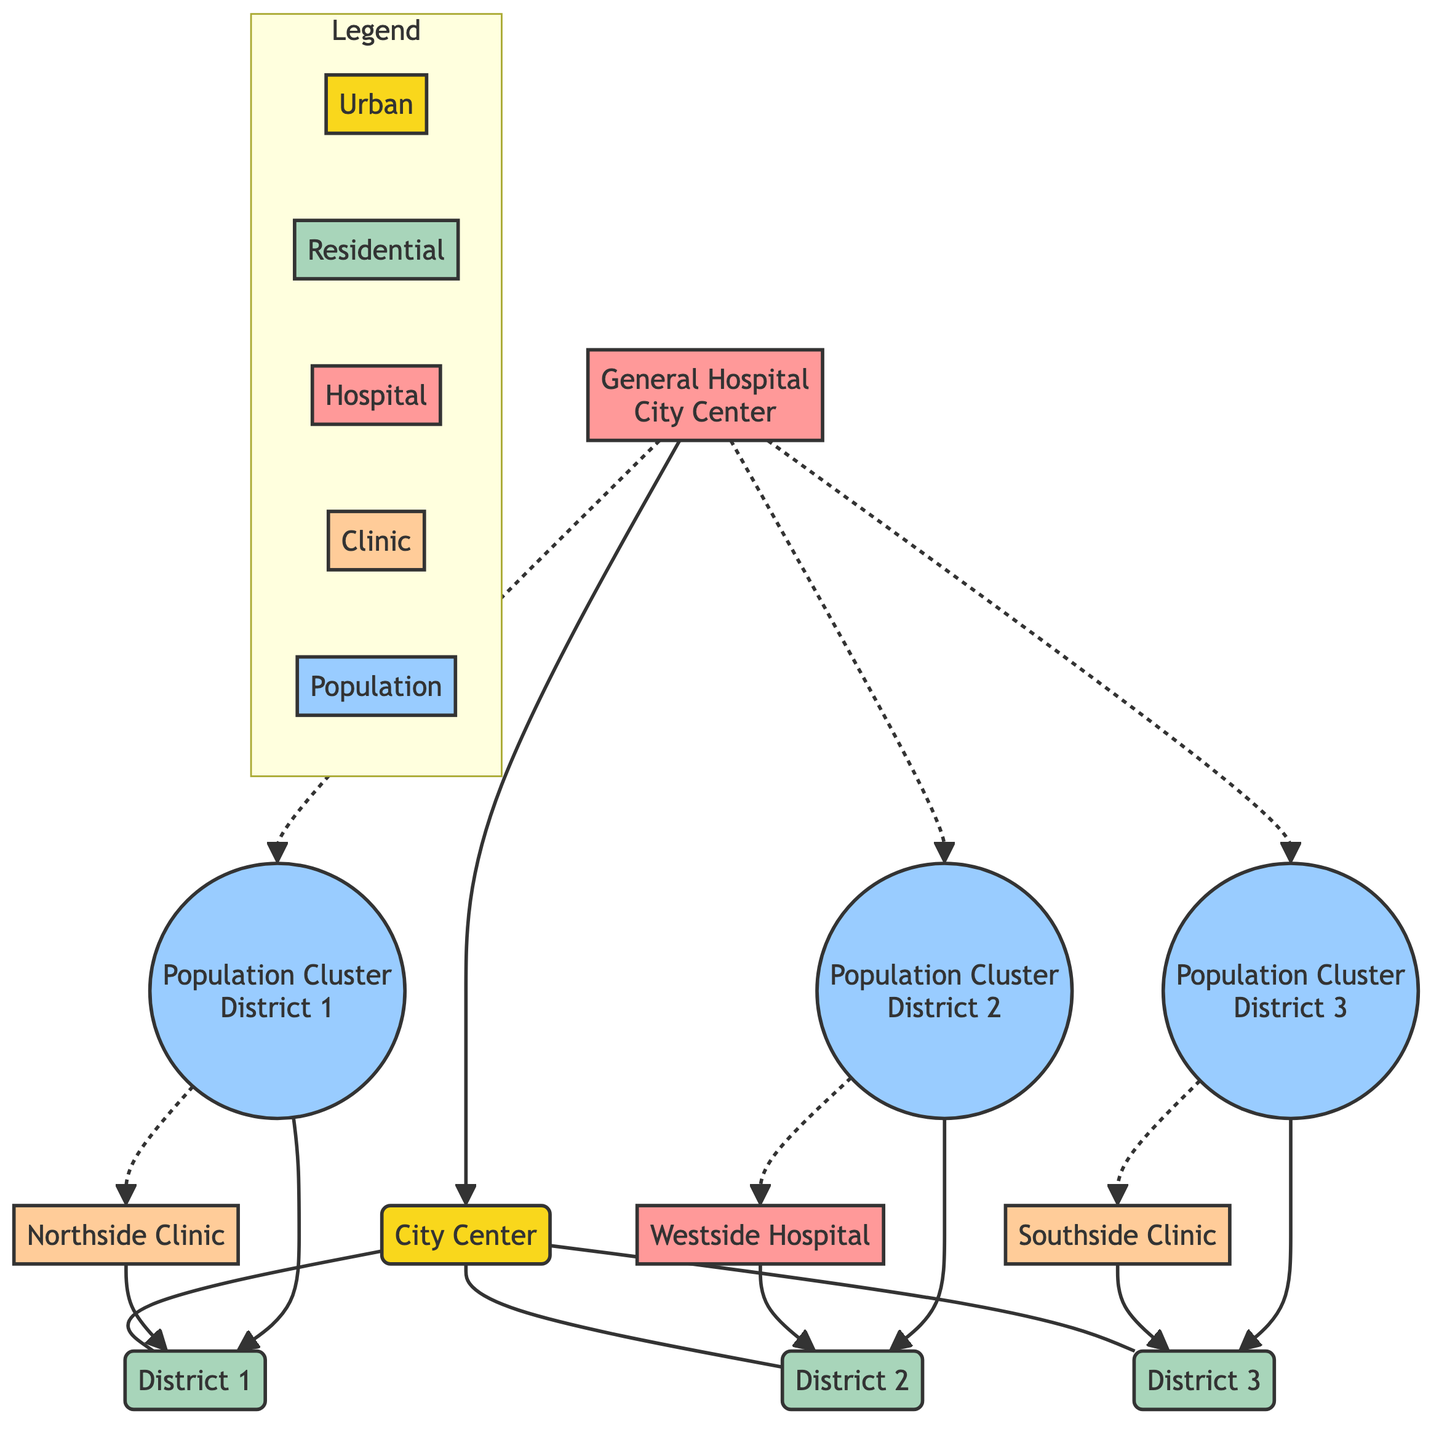What is located in the City Center? The diagram indicates that the City Center is home to the General Hospital. This is determined by looking at the nodes connected to City Center and identifying the hospital node directly linked to it.
Answer: General Hospital How many residential districts are mapped? The diagram shows three distinct nodes representing residential districts: District 1, District 2, and District 3. Counting these nodes gives a total of three residential districts.
Answer: Three Which clinic is connected to District 1? By examining the connections from District 1, it is evident that the Northside Clinic is directly linked to it. The visual representation makes it clear that this clinic serves that district.
Answer: Northside Clinic Which population cluster is closest to the hospital located in District 2? The diagram shows that the population cluster in District 2 is connected by a dashed line to the hospital in District 2, which indicates that this population cluster is served by that hospital. Following these connections leads to the conclusion that the hospital serving District 2 is closest to its own population cluster.
Answer: Population Cluster District 2 What type of facility connects to District 3? The visual shows that the Southside Clinic connects directly to District 3. This direct connection identifies the type of healthcare facility available in that district.
Answer: Clinic What is the relation between the General Hospital and the population clusters? The General Hospital has dashed line connections to all three population clusters (District 1, District 2, and District 3), indicating that it serves patients from each of these areas. This relationship shows the hospital's outreach and accessibility in relation to these population centers.
Answer: Serves all clusters Which districts are underserved compared to the City Center? By analyzing the flow of connections, it becomes clear that District 1, District 2, and District 3 rely more on Clinic and Hospital services in their own districts rather than having the same level of access as the City Center, where the General Hospital is directly located. Therefore, these districts could be considered underserved in comparison.
Answer: District 1, District 2, District 3 What is the significance of dashed lines in the diagram? The dashed lines in the diagram indicate indirect connections, showing that while the General Hospital and population clusters are not directly linked, there is still an implied accessibility or service relationship between them. This visual style differentiates between direct and indirect connections, emphasizing the broader reach of the hospital's services.
Answer: Indirect connections 